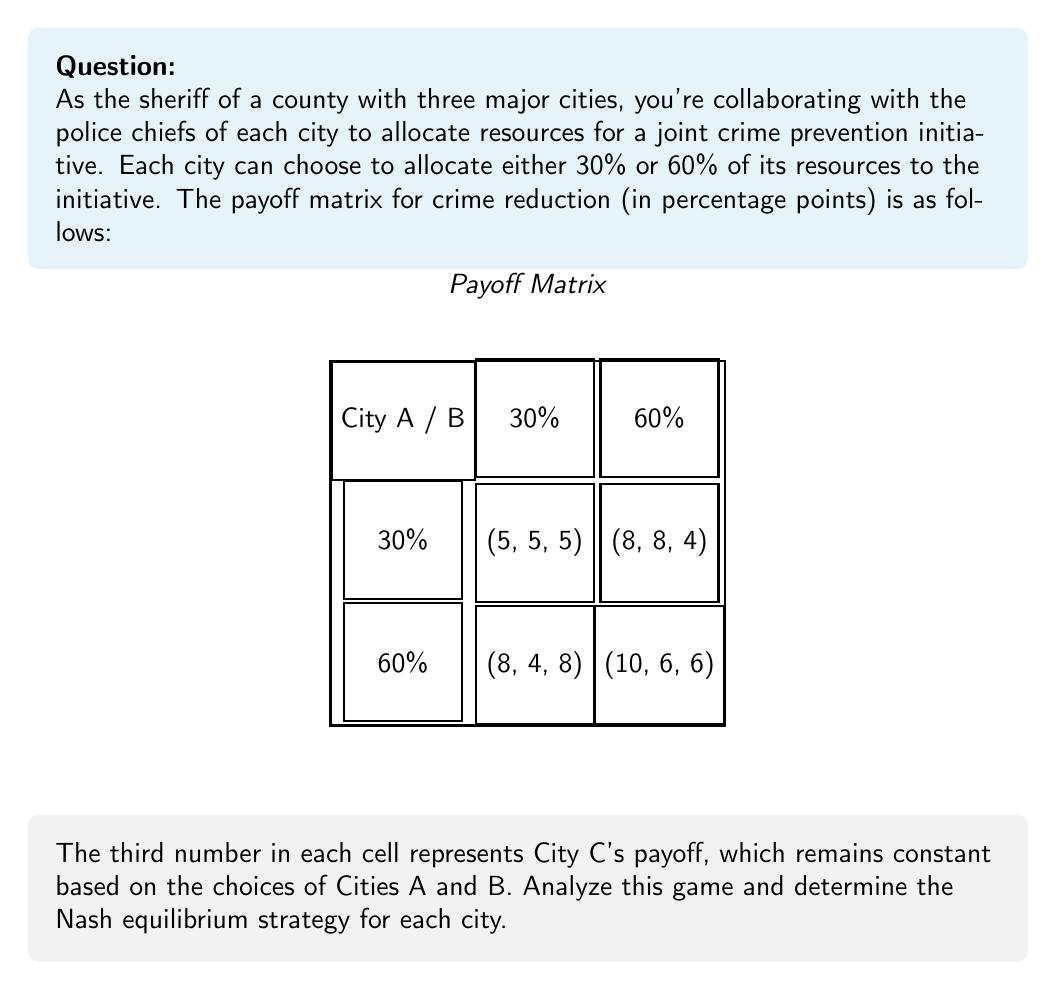Can you answer this question? To find the Nash equilibrium, we need to analyze each city's best response to the other cities' strategies:

1. For City C:
   - City C's payoff is always highest (8%) when Cities A and B both choose 30%.
   - In all other cases, City C's payoff is lower (5%, 4%, or 6%).
   - Therefore, City C's dominant strategy is to always choose 60%.

2. Given City C's dominant strategy of 60%, we can simplify the game to a 2x2 matrix for Cities A and B:

   $$
   \begin{array}{c|c|c}
   \text{A} \backslash \text{B} & 30\% & 60\% \\
   \hline
   30\% & (5, 5) & (8, 8) \\
   \hline
   60\% & (8, 4) & (10, 6)
   \end{array}
   $$

3. Analyzing City A's strategies:
   - If B chooses 30%, A prefers 60% (8 > 5)
   - If B chooses 60%, A prefers 60% (10 > 8)

4. Analyzing City B's strategies:
   - If A chooses 30%, B prefers 60% (8 > 5)
   - If A chooses 60%, B prefers 60% (6 > 4)

5. The Nash equilibrium occurs when both cities choose their best responses simultaneously. In this case, both City A and City B have a dominant strategy of 60%.

Therefore, the Nash equilibrium strategy profile is:
- City A: 60%
- City B: 60%
- City C: 60%

At this equilibrium, no city can unilaterally improve its payoff by changing its strategy.
Answer: (60%, 60%, 60%) 